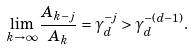Convert formula to latex. <formula><loc_0><loc_0><loc_500><loc_500>\lim _ { k \to \infty } \frac { A _ { k - j } } { A _ { k } } = \gamma _ { d } ^ { - j } > \gamma _ { d } ^ { - ( d - 1 ) } .</formula> 